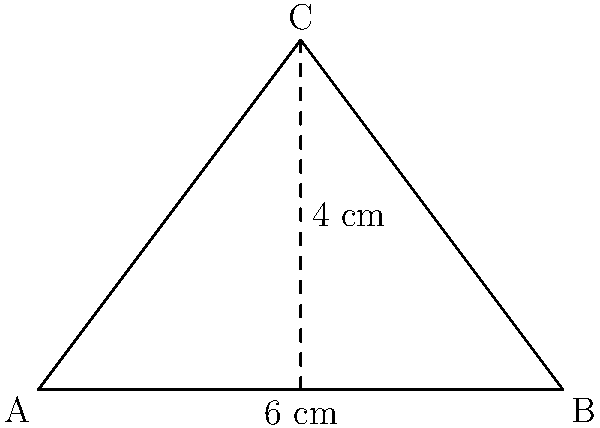During a labor dispute, a triangular protest sign needs to be created. The base of the sign measures 6 cm, and its height is 4 cm. Calculate the area of the triangular protest sign to determine the amount of material needed. To find the area of a triangle, we use the formula:

$$A = \frac{1}{2} \times b \times h$$

Where:
$A$ = Area of the triangle
$b$ = Base of the triangle
$h$ = Height of the triangle

Given:
Base $(b) = 6$ cm
Height $(h) = 4$ cm

Step 1: Substitute the values into the formula
$$A = \frac{1}{2} \times 6 \times 4$$

Step 2: Multiply the numbers
$$A = \frac{1}{2} \times 24$$

Step 3: Calculate the final result
$$A = 12$$

Therefore, the area of the triangular protest sign is 12 square centimeters.
Answer: 12 cm² 